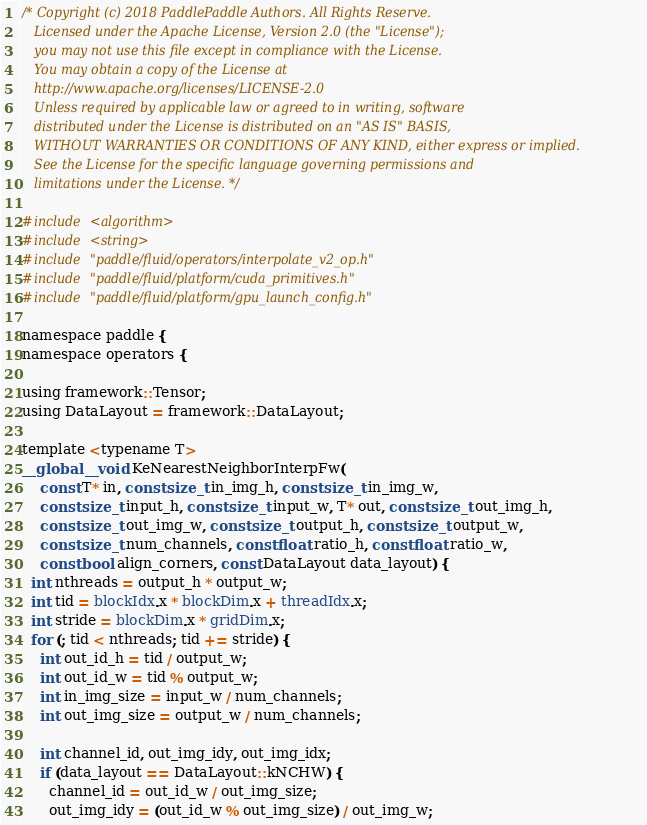Convert code to text. <code><loc_0><loc_0><loc_500><loc_500><_Cuda_>/* Copyright (c) 2018 PaddlePaddle Authors. All Rights Reserve.
   Licensed under the Apache License, Version 2.0 (the "License");
   you may not use this file except in compliance with the License.
   You may obtain a copy of the License at
   http://www.apache.org/licenses/LICENSE-2.0
   Unless required by applicable law or agreed to in writing, software
   distributed under the License is distributed on an "AS IS" BASIS,
   WITHOUT WARRANTIES OR CONDITIONS OF ANY KIND, either express or implied.
   See the License for the specific language governing permissions and
   limitations under the License. */

#include <algorithm>
#include <string>
#include "paddle/fluid/operators/interpolate_v2_op.h"
#include "paddle/fluid/platform/cuda_primitives.h"
#include "paddle/fluid/platform/gpu_launch_config.h"

namespace paddle {
namespace operators {

using framework::Tensor;
using DataLayout = framework::DataLayout;

template <typename T>
__global__ void KeNearestNeighborInterpFw(
    const T* in, const size_t in_img_h, const size_t in_img_w,
    const size_t input_h, const size_t input_w, T* out, const size_t out_img_h,
    const size_t out_img_w, const size_t output_h, const size_t output_w,
    const size_t num_channels, const float ratio_h, const float ratio_w,
    const bool align_corners, const DataLayout data_layout) {
  int nthreads = output_h * output_w;
  int tid = blockIdx.x * blockDim.x + threadIdx.x;
  int stride = blockDim.x * gridDim.x;
  for (; tid < nthreads; tid += stride) {
    int out_id_h = tid / output_w;
    int out_id_w = tid % output_w;
    int in_img_size = input_w / num_channels;
    int out_img_size = output_w / num_channels;

    int channel_id, out_img_idy, out_img_idx;
    if (data_layout == DataLayout::kNCHW) {
      channel_id = out_id_w / out_img_size;
      out_img_idy = (out_id_w % out_img_size) / out_img_w;</code> 